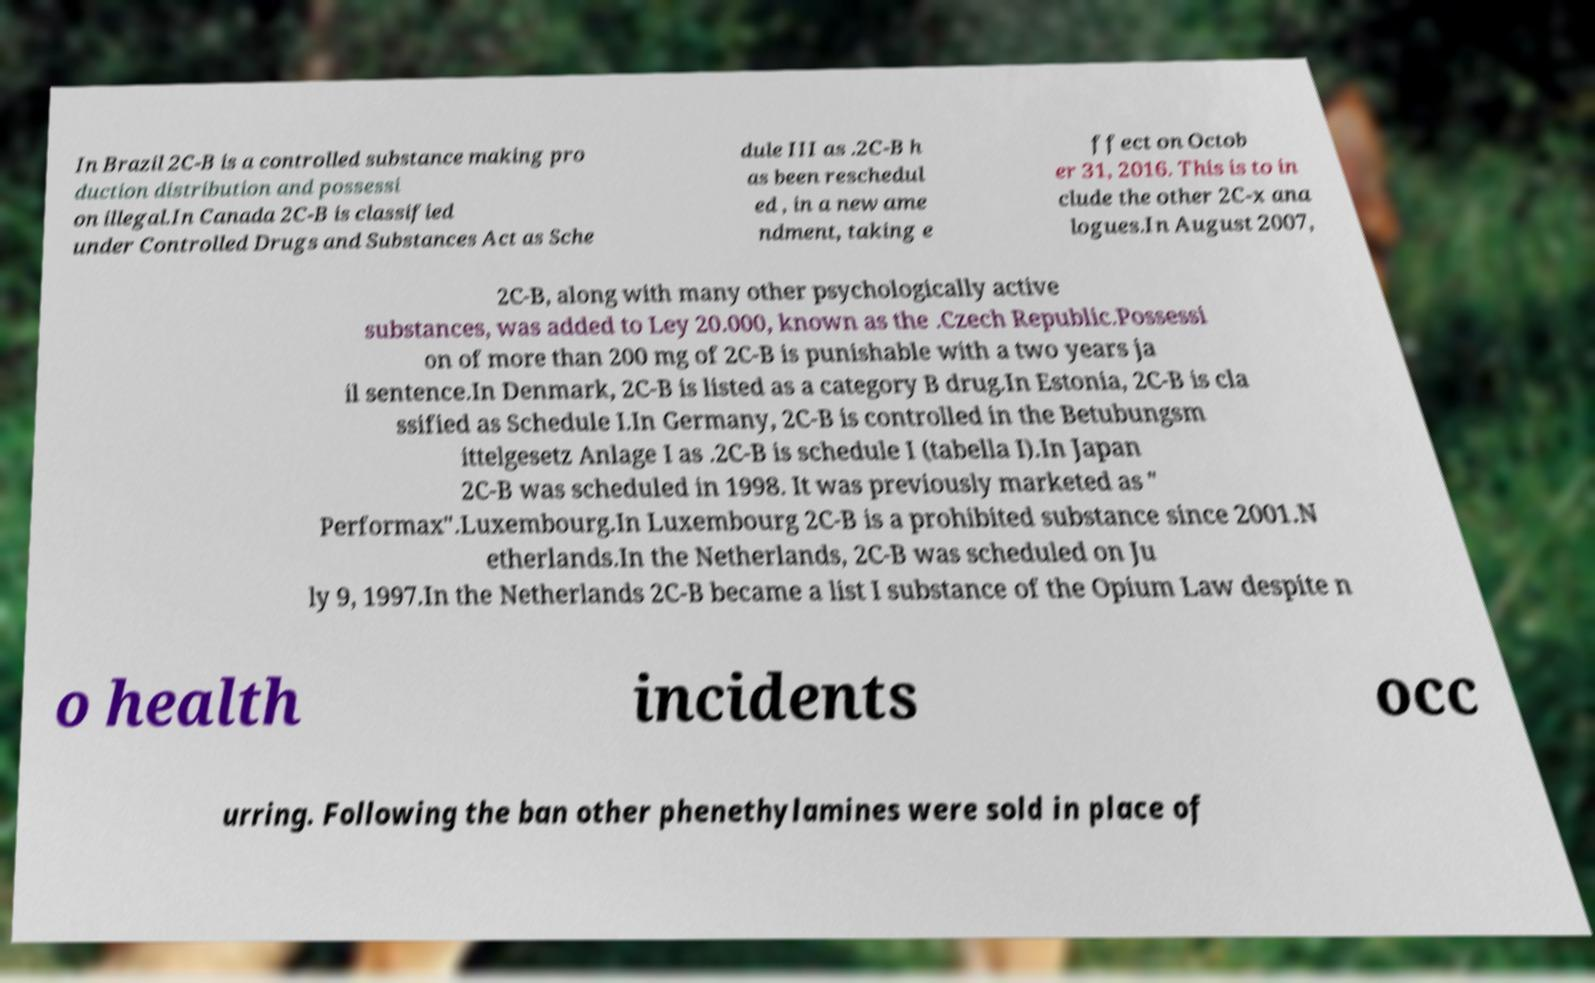I need the written content from this picture converted into text. Can you do that? In Brazil 2C-B is a controlled substance making pro duction distribution and possessi on illegal.In Canada 2C-B is classified under Controlled Drugs and Substances Act as Sche dule III as .2C-B h as been reschedul ed , in a new ame ndment, taking e ffect on Octob er 31, 2016. This is to in clude the other 2C-x ana logues.In August 2007, 2C-B, along with many other psychologically active substances, was added to Ley 20.000, known as the .Czech Republic.Possessi on of more than 200 mg of 2C-B is punishable with a two years ja il sentence.In Denmark, 2C-B is listed as a category B drug.In Estonia, 2C-B is cla ssified as Schedule I.In Germany, 2C-B is controlled in the Betubungsm ittelgesetz Anlage I as .2C-B is schedule I (tabella I).In Japan 2C-B was scheduled in 1998. It was previously marketed as " Performax".Luxembourg.In Luxembourg 2C-B is a prohibited substance since 2001.N etherlands.In the Netherlands, 2C-B was scheduled on Ju ly 9, 1997.In the Netherlands 2C-B became a list I substance of the Opium Law despite n o health incidents occ urring. Following the ban other phenethylamines were sold in place of 